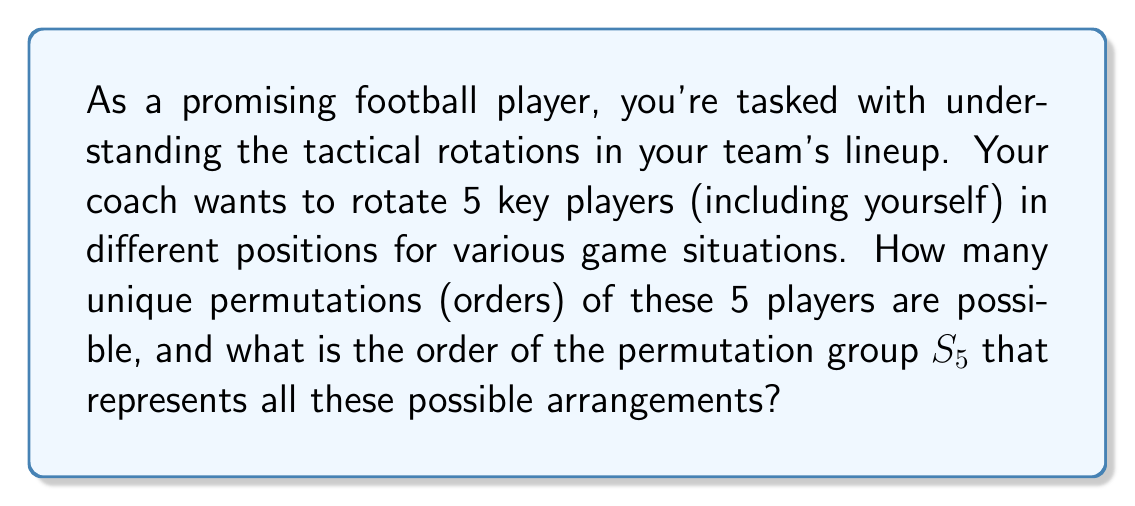Provide a solution to this math problem. To solve this problem, we need to understand the concept of permutation groups in abstract algebra:

1) A permutation of $n$ elements is an arrangement of these elements in a specific order.

2) The set of all permutations of $n$ elements forms a group called the symmetric group, denoted as $S_n$.

3) The order of a group is the number of elements in the group.

4) For a set of $n$ distinct elements, the number of possible permutations is $n!$ (n factorial).

In this case, we have 5 players, so we're dealing with $S_5$.

To calculate the order of $S_5$:

$$|S_5| = 5! = 5 \times 4 \times 3 \times 2 \times 1 = 120$$

This means there are 120 possible unique arrangements of the 5 players.

Each of these permutations represents a different tactical lineup, allowing the coach to adapt to various game situations.

Understanding this concept can help a promising player appreciate the complexity of tactical decisions and the importance of versatility in different positions.
Answer: The order of the permutation group $S_5$, representing all possible arrangements of 5 players, is 120. 